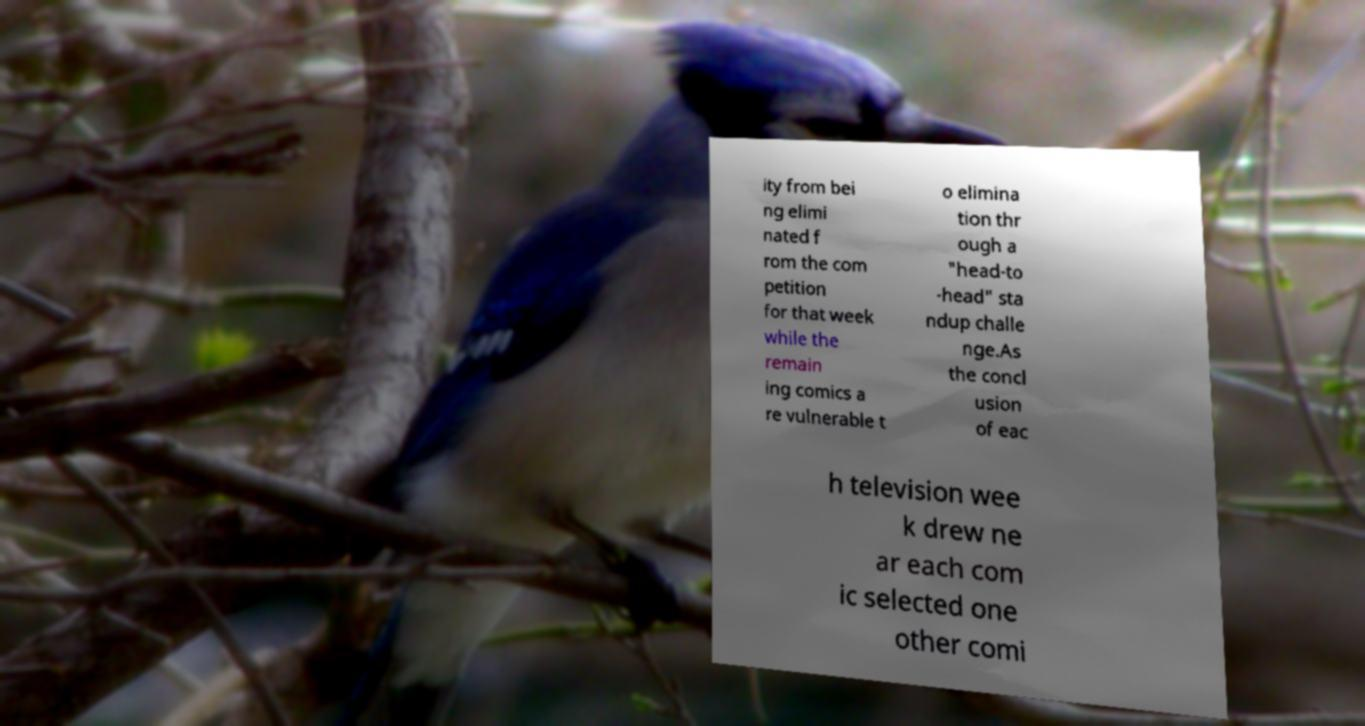Could you assist in decoding the text presented in this image and type it out clearly? ity from bei ng elimi nated f rom the com petition for that week while the remain ing comics a re vulnerable t o elimina tion thr ough a "head-to -head" sta ndup challe nge.As the concl usion of eac h television wee k drew ne ar each com ic selected one other comi 